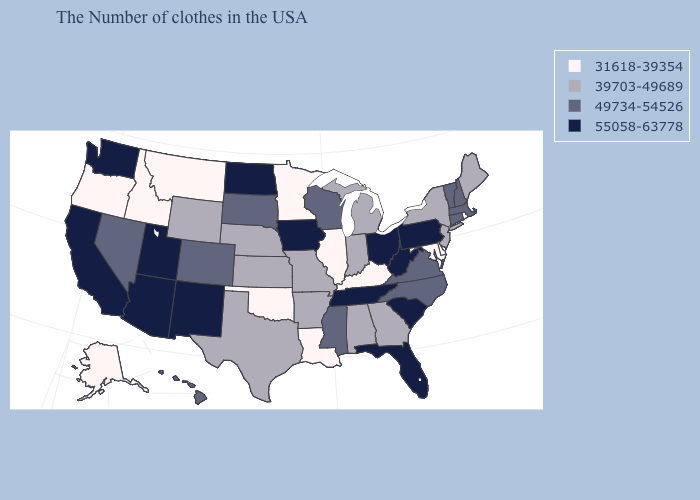How many symbols are there in the legend?
Write a very short answer. 4. What is the value of Louisiana?
Answer briefly. 31618-39354. What is the value of Mississippi?
Answer briefly. 49734-54526. Name the states that have a value in the range 39703-49689?
Short answer required. Maine, New York, New Jersey, Georgia, Michigan, Indiana, Alabama, Missouri, Arkansas, Kansas, Nebraska, Texas, Wyoming. What is the lowest value in states that border Pennsylvania?
Short answer required. 31618-39354. What is the value of Maryland?
Short answer required. 31618-39354. Name the states that have a value in the range 39703-49689?
Give a very brief answer. Maine, New York, New Jersey, Georgia, Michigan, Indiana, Alabama, Missouri, Arkansas, Kansas, Nebraska, Texas, Wyoming. Does the map have missing data?
Give a very brief answer. No. Name the states that have a value in the range 31618-39354?
Give a very brief answer. Rhode Island, Delaware, Maryland, Kentucky, Illinois, Louisiana, Minnesota, Oklahoma, Montana, Idaho, Oregon, Alaska. What is the value of Arkansas?
Concise answer only. 39703-49689. Does the map have missing data?
Give a very brief answer. No. Is the legend a continuous bar?
Keep it brief. No. Name the states that have a value in the range 55058-63778?
Give a very brief answer. Pennsylvania, South Carolina, West Virginia, Ohio, Florida, Tennessee, Iowa, North Dakota, New Mexico, Utah, Arizona, California, Washington. Which states have the lowest value in the West?
Concise answer only. Montana, Idaho, Oregon, Alaska. 